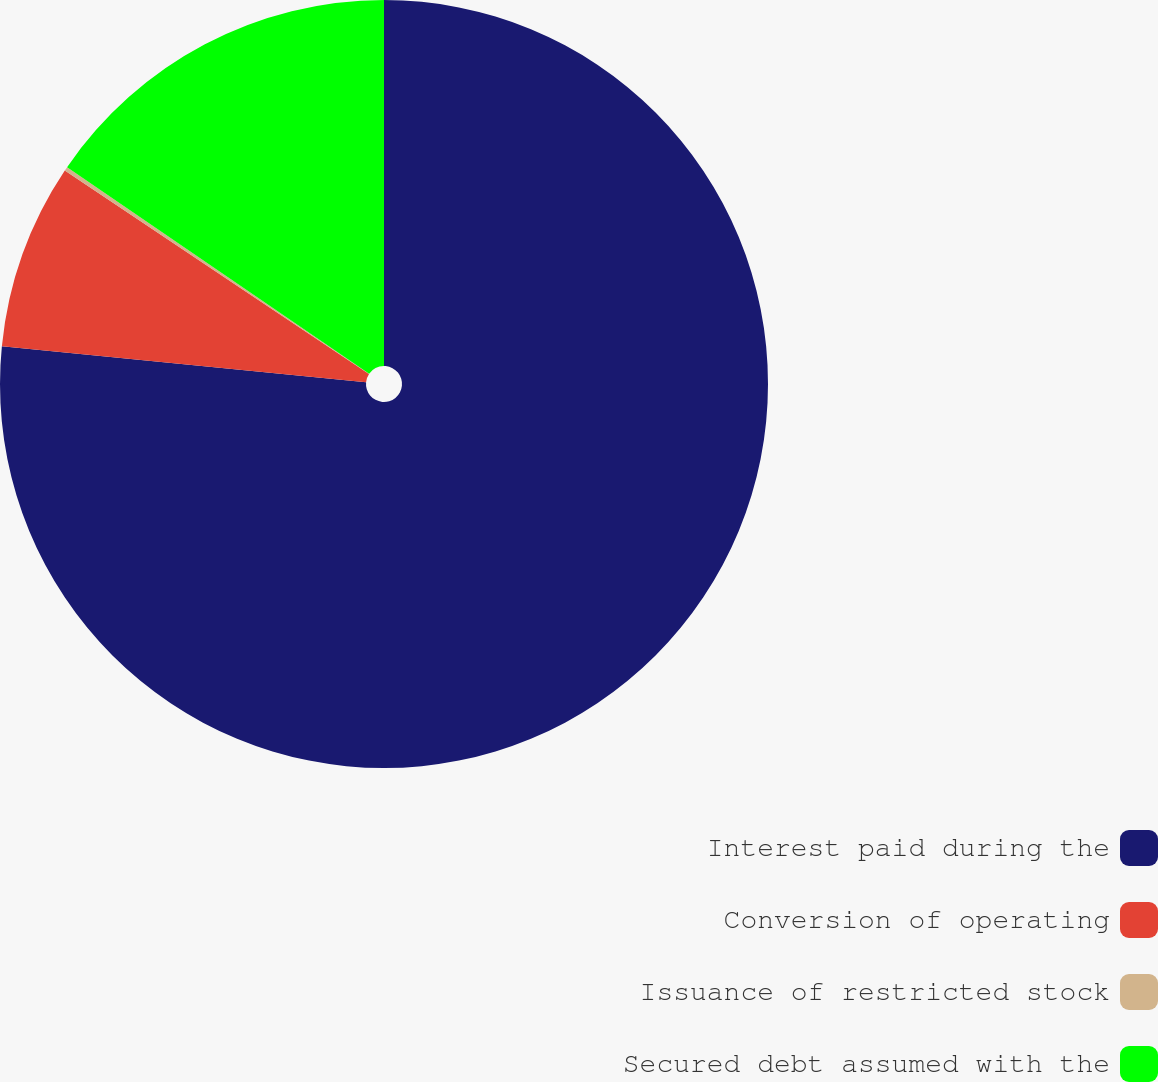<chart> <loc_0><loc_0><loc_500><loc_500><pie_chart><fcel>Interest paid during the<fcel>Conversion of operating<fcel>Issuance of restricted stock<fcel>Secured debt assumed with the<nl><fcel>76.58%<fcel>7.81%<fcel>0.17%<fcel>15.45%<nl></chart> 